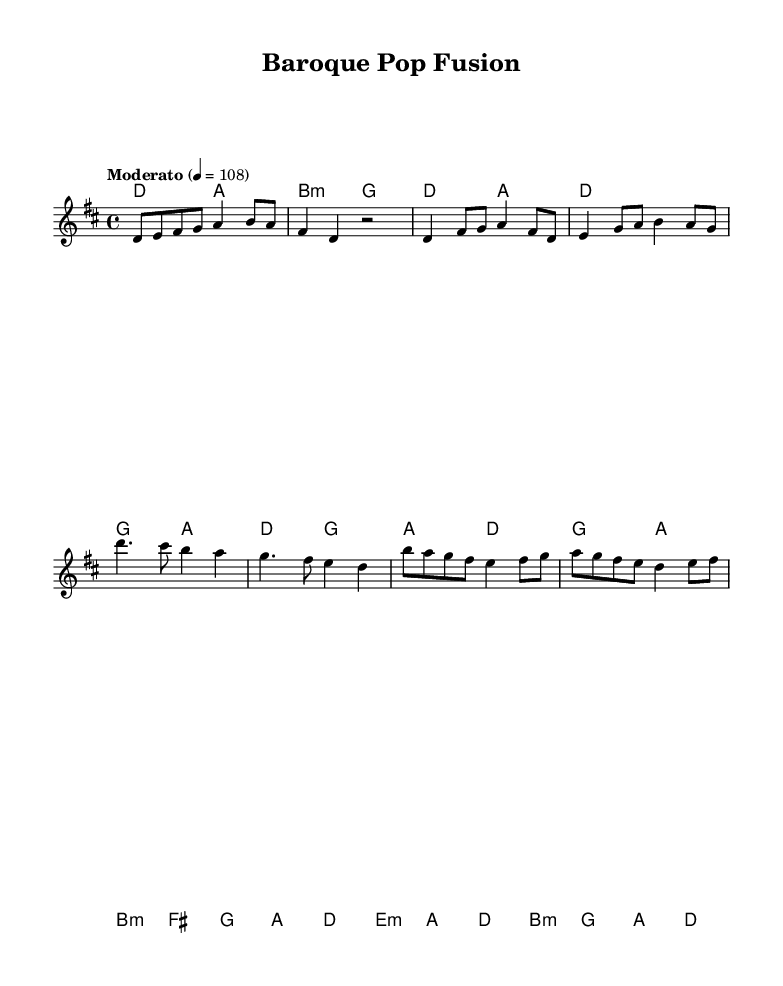What is the key signature of this music? The key signature is D major, which has two sharps (F# and C#). This can be determined by looking at the key signature in the beginning of the sheet music, just after the clef.
Answer: D major What is the time signature of this music? The time signature is 4/4, indicated at the beginning of the score. This suggests that there are four beats in each measure, and the quarter note gets one beat.
Answer: 4/4 What is the tempo marking of this piece? The tempo marking is "Moderato," which suggests a moderate speed for the performance. It is indicated above the staff at the beginning, followed by the metronome marking of 108 beats per minute.
Answer: Moderato How many measures are in the intro section? The intro section contains two measures, which can be identified by counting the sections before the first verse starts. Each measure is separated by vertical lines on the staff.
Answer: 2 What chord is played in the first measure of the intro? The chord in the first measure of the intro is D major, as indicated in the chord symbols written above the staff. The symbol "d" denotes D major.
Answer: D What is the melodic range of the piece? The melodic range extends from D in the middle octave (three ledger lines to the bottom) to B in a higher octave (two ledger lines above the staff). This span is observed by examining the highest and lowest notes in the melody.
Answer: D to B What musical form does the piece follow? The piece follows a verse-chorus form, which can be inferred from the structured phrases labeled as intro, verse, chorus, and bridge. Each section has distinct musical ideas and emotional content typical of pop music.
Answer: Verse-chorus 